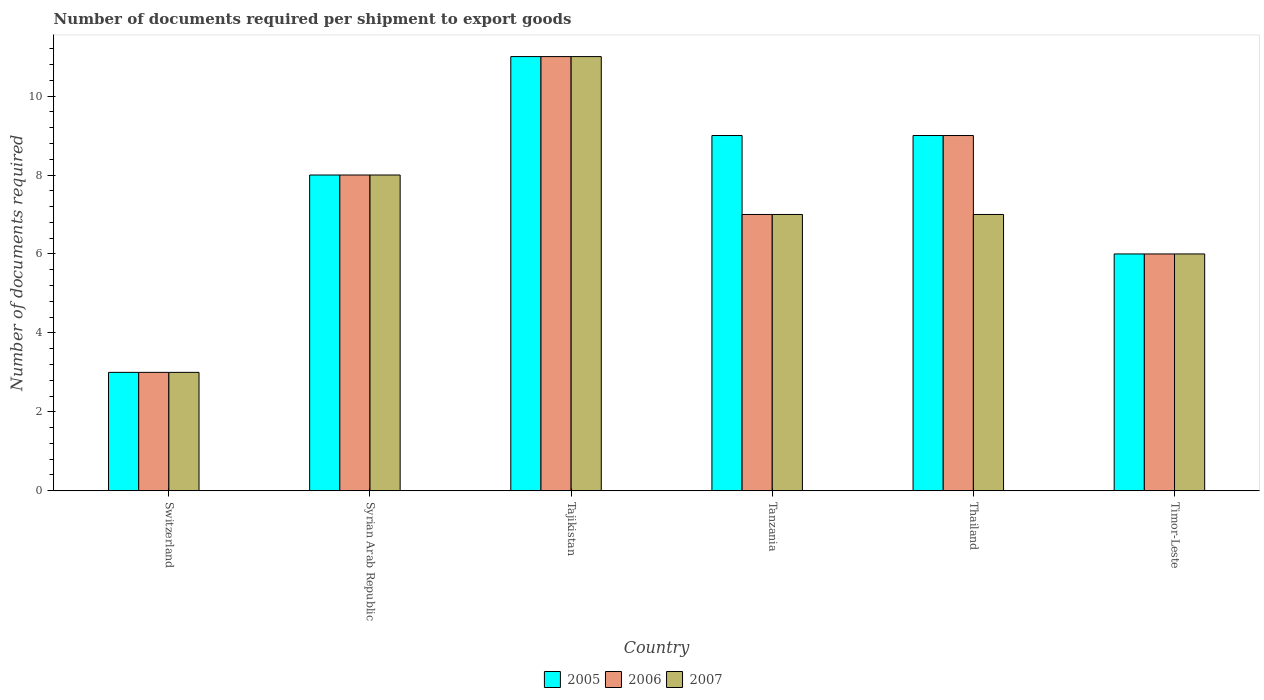How many different coloured bars are there?
Give a very brief answer. 3. Are the number of bars per tick equal to the number of legend labels?
Your response must be concise. Yes. How many bars are there on the 3rd tick from the left?
Provide a succinct answer. 3. How many bars are there on the 3rd tick from the right?
Offer a terse response. 3. What is the label of the 2nd group of bars from the left?
Your response must be concise. Syrian Arab Republic. What is the number of documents required per shipment to export goods in 2006 in Syrian Arab Republic?
Keep it short and to the point. 8. In which country was the number of documents required per shipment to export goods in 2007 maximum?
Keep it short and to the point. Tajikistan. In which country was the number of documents required per shipment to export goods in 2006 minimum?
Provide a succinct answer. Switzerland. What is the difference between the number of documents required per shipment to export goods in 2006 in Switzerland and that in Syrian Arab Republic?
Make the answer very short. -5. What is the average number of documents required per shipment to export goods in 2006 per country?
Ensure brevity in your answer.  7.33. What is the difference between the number of documents required per shipment to export goods of/in 2006 and number of documents required per shipment to export goods of/in 2005 in Thailand?
Provide a short and direct response. 0. In how many countries, is the number of documents required per shipment to export goods in 2007 greater than 4?
Your answer should be very brief. 5. What is the ratio of the number of documents required per shipment to export goods in 2007 in Syrian Arab Republic to that in Tanzania?
Offer a very short reply. 1.14. Is the number of documents required per shipment to export goods in 2007 in Tajikistan less than that in Timor-Leste?
Keep it short and to the point. No. Is the difference between the number of documents required per shipment to export goods in 2006 in Switzerland and Tanzania greater than the difference between the number of documents required per shipment to export goods in 2005 in Switzerland and Tanzania?
Keep it short and to the point. Yes. In how many countries, is the number of documents required per shipment to export goods in 2007 greater than the average number of documents required per shipment to export goods in 2007 taken over all countries?
Keep it short and to the point. 2. Is the sum of the number of documents required per shipment to export goods in 2007 in Tajikistan and Timor-Leste greater than the maximum number of documents required per shipment to export goods in 2005 across all countries?
Offer a very short reply. Yes. Is it the case that in every country, the sum of the number of documents required per shipment to export goods in 2005 and number of documents required per shipment to export goods in 2007 is greater than the number of documents required per shipment to export goods in 2006?
Ensure brevity in your answer.  Yes. Are all the bars in the graph horizontal?
Offer a very short reply. No. How many countries are there in the graph?
Provide a short and direct response. 6. What is the difference between two consecutive major ticks on the Y-axis?
Your response must be concise. 2. Does the graph contain grids?
Offer a terse response. No. How many legend labels are there?
Ensure brevity in your answer.  3. How are the legend labels stacked?
Ensure brevity in your answer.  Horizontal. What is the title of the graph?
Ensure brevity in your answer.  Number of documents required per shipment to export goods. Does "1988" appear as one of the legend labels in the graph?
Your response must be concise. No. What is the label or title of the X-axis?
Offer a very short reply. Country. What is the label or title of the Y-axis?
Provide a short and direct response. Number of documents required. What is the Number of documents required in 2005 in Switzerland?
Ensure brevity in your answer.  3. What is the Number of documents required of 2006 in Switzerland?
Make the answer very short. 3. What is the Number of documents required in 2007 in Switzerland?
Ensure brevity in your answer.  3. What is the Number of documents required of 2005 in Syrian Arab Republic?
Provide a succinct answer. 8. What is the Number of documents required of 2006 in Syrian Arab Republic?
Ensure brevity in your answer.  8. What is the Number of documents required in 2007 in Syrian Arab Republic?
Provide a succinct answer. 8. What is the Number of documents required in 2005 in Tajikistan?
Your response must be concise. 11. What is the Number of documents required in 2007 in Tajikistan?
Your answer should be compact. 11. What is the Number of documents required in 2005 in Tanzania?
Your answer should be compact. 9. What is the Number of documents required of 2006 in Tanzania?
Keep it short and to the point. 7. What is the Number of documents required of 2007 in Tanzania?
Provide a succinct answer. 7. What is the Number of documents required of 2005 in Thailand?
Provide a short and direct response. 9. What is the Number of documents required of 2006 in Thailand?
Make the answer very short. 9. What is the Number of documents required in 2005 in Timor-Leste?
Your answer should be compact. 6. What is the Number of documents required in 2007 in Timor-Leste?
Your answer should be compact. 6. Across all countries, what is the minimum Number of documents required of 2006?
Ensure brevity in your answer.  3. What is the total Number of documents required in 2005 in the graph?
Give a very brief answer. 46. What is the total Number of documents required of 2006 in the graph?
Your response must be concise. 44. What is the difference between the Number of documents required in 2005 in Switzerland and that in Syrian Arab Republic?
Provide a succinct answer. -5. What is the difference between the Number of documents required of 2006 in Switzerland and that in Syrian Arab Republic?
Make the answer very short. -5. What is the difference between the Number of documents required in 2007 in Switzerland and that in Syrian Arab Republic?
Your answer should be very brief. -5. What is the difference between the Number of documents required in 2005 in Switzerland and that in Tajikistan?
Provide a succinct answer. -8. What is the difference between the Number of documents required in 2006 in Switzerland and that in Tajikistan?
Your answer should be compact. -8. What is the difference between the Number of documents required in 2007 in Switzerland and that in Tajikistan?
Your answer should be very brief. -8. What is the difference between the Number of documents required in 2007 in Switzerland and that in Tanzania?
Keep it short and to the point. -4. What is the difference between the Number of documents required in 2005 in Switzerland and that in Thailand?
Offer a very short reply. -6. What is the difference between the Number of documents required of 2007 in Switzerland and that in Thailand?
Give a very brief answer. -4. What is the difference between the Number of documents required of 2005 in Switzerland and that in Timor-Leste?
Your response must be concise. -3. What is the difference between the Number of documents required of 2007 in Switzerland and that in Timor-Leste?
Offer a terse response. -3. What is the difference between the Number of documents required in 2006 in Syrian Arab Republic and that in Tajikistan?
Your answer should be compact. -3. What is the difference between the Number of documents required in 2006 in Syrian Arab Republic and that in Tanzania?
Ensure brevity in your answer.  1. What is the difference between the Number of documents required in 2005 in Syrian Arab Republic and that in Thailand?
Offer a terse response. -1. What is the difference between the Number of documents required in 2006 in Syrian Arab Republic and that in Thailand?
Your answer should be very brief. -1. What is the difference between the Number of documents required of 2005 in Tajikistan and that in Tanzania?
Offer a very short reply. 2. What is the difference between the Number of documents required in 2007 in Tajikistan and that in Tanzania?
Your answer should be compact. 4. What is the difference between the Number of documents required of 2005 in Tajikistan and that in Thailand?
Offer a terse response. 2. What is the difference between the Number of documents required in 2006 in Tajikistan and that in Thailand?
Your response must be concise. 2. What is the difference between the Number of documents required of 2005 in Tajikistan and that in Timor-Leste?
Your answer should be compact. 5. What is the difference between the Number of documents required in 2006 in Tajikistan and that in Timor-Leste?
Your response must be concise. 5. What is the difference between the Number of documents required of 2007 in Tanzania and that in Thailand?
Ensure brevity in your answer.  0. What is the difference between the Number of documents required of 2005 in Tanzania and that in Timor-Leste?
Provide a short and direct response. 3. What is the difference between the Number of documents required in 2006 in Tanzania and that in Timor-Leste?
Provide a succinct answer. 1. What is the difference between the Number of documents required in 2005 in Thailand and that in Timor-Leste?
Your answer should be very brief. 3. What is the difference between the Number of documents required in 2006 in Thailand and that in Timor-Leste?
Your response must be concise. 3. What is the difference between the Number of documents required of 2005 in Switzerland and the Number of documents required of 2007 in Syrian Arab Republic?
Make the answer very short. -5. What is the difference between the Number of documents required of 2006 in Switzerland and the Number of documents required of 2007 in Syrian Arab Republic?
Provide a succinct answer. -5. What is the difference between the Number of documents required of 2005 in Switzerland and the Number of documents required of 2007 in Tanzania?
Give a very brief answer. -4. What is the difference between the Number of documents required in 2005 in Switzerland and the Number of documents required in 2006 in Thailand?
Ensure brevity in your answer.  -6. What is the difference between the Number of documents required in 2006 in Switzerland and the Number of documents required in 2007 in Thailand?
Your answer should be compact. -4. What is the difference between the Number of documents required of 2006 in Switzerland and the Number of documents required of 2007 in Timor-Leste?
Your response must be concise. -3. What is the difference between the Number of documents required of 2006 in Syrian Arab Republic and the Number of documents required of 2007 in Tajikistan?
Your answer should be compact. -3. What is the difference between the Number of documents required in 2005 in Syrian Arab Republic and the Number of documents required in 2006 in Tanzania?
Your response must be concise. 1. What is the difference between the Number of documents required in 2005 in Syrian Arab Republic and the Number of documents required in 2007 in Tanzania?
Your answer should be compact. 1. What is the difference between the Number of documents required in 2006 in Syrian Arab Republic and the Number of documents required in 2007 in Tanzania?
Provide a succinct answer. 1. What is the difference between the Number of documents required in 2005 in Syrian Arab Republic and the Number of documents required in 2006 in Timor-Leste?
Ensure brevity in your answer.  2. What is the difference between the Number of documents required of 2005 in Syrian Arab Republic and the Number of documents required of 2007 in Timor-Leste?
Provide a short and direct response. 2. What is the difference between the Number of documents required in 2006 in Syrian Arab Republic and the Number of documents required in 2007 in Timor-Leste?
Give a very brief answer. 2. What is the difference between the Number of documents required in 2005 in Tajikistan and the Number of documents required in 2006 in Tanzania?
Your answer should be compact. 4. What is the difference between the Number of documents required of 2005 in Tajikistan and the Number of documents required of 2006 in Thailand?
Ensure brevity in your answer.  2. What is the difference between the Number of documents required of 2005 in Tajikistan and the Number of documents required of 2006 in Timor-Leste?
Make the answer very short. 5. What is the difference between the Number of documents required of 2005 in Tajikistan and the Number of documents required of 2007 in Timor-Leste?
Keep it short and to the point. 5. What is the difference between the Number of documents required of 2006 in Tajikistan and the Number of documents required of 2007 in Timor-Leste?
Offer a very short reply. 5. What is the difference between the Number of documents required of 2005 in Tanzania and the Number of documents required of 2006 in Thailand?
Provide a succinct answer. 0. What is the difference between the Number of documents required in 2005 in Tanzania and the Number of documents required in 2007 in Thailand?
Ensure brevity in your answer.  2. What is the difference between the Number of documents required of 2006 in Tanzania and the Number of documents required of 2007 in Thailand?
Your answer should be compact. 0. What is the difference between the Number of documents required in 2005 in Thailand and the Number of documents required in 2006 in Timor-Leste?
Provide a succinct answer. 3. What is the difference between the Number of documents required in 2006 in Thailand and the Number of documents required in 2007 in Timor-Leste?
Keep it short and to the point. 3. What is the average Number of documents required of 2005 per country?
Offer a terse response. 7.67. What is the average Number of documents required of 2006 per country?
Ensure brevity in your answer.  7.33. What is the average Number of documents required of 2007 per country?
Your answer should be compact. 7. What is the difference between the Number of documents required of 2005 and Number of documents required of 2006 in Switzerland?
Ensure brevity in your answer.  0. What is the difference between the Number of documents required of 2006 and Number of documents required of 2007 in Switzerland?
Ensure brevity in your answer.  0. What is the difference between the Number of documents required of 2006 and Number of documents required of 2007 in Syrian Arab Republic?
Offer a terse response. 0. What is the difference between the Number of documents required in 2005 and Number of documents required in 2006 in Tajikistan?
Your response must be concise. 0. What is the difference between the Number of documents required of 2005 and Number of documents required of 2006 in Tanzania?
Provide a short and direct response. 2. What is the difference between the Number of documents required of 2006 and Number of documents required of 2007 in Tanzania?
Ensure brevity in your answer.  0. What is the difference between the Number of documents required in 2005 and Number of documents required in 2007 in Thailand?
Give a very brief answer. 2. What is the difference between the Number of documents required of 2005 and Number of documents required of 2006 in Timor-Leste?
Give a very brief answer. 0. What is the difference between the Number of documents required in 2005 and Number of documents required in 2007 in Timor-Leste?
Offer a terse response. 0. What is the ratio of the Number of documents required of 2006 in Switzerland to that in Syrian Arab Republic?
Your answer should be compact. 0.38. What is the ratio of the Number of documents required of 2005 in Switzerland to that in Tajikistan?
Your answer should be compact. 0.27. What is the ratio of the Number of documents required of 2006 in Switzerland to that in Tajikistan?
Provide a succinct answer. 0.27. What is the ratio of the Number of documents required in 2007 in Switzerland to that in Tajikistan?
Your answer should be very brief. 0.27. What is the ratio of the Number of documents required in 2005 in Switzerland to that in Tanzania?
Offer a very short reply. 0.33. What is the ratio of the Number of documents required in 2006 in Switzerland to that in Tanzania?
Your answer should be compact. 0.43. What is the ratio of the Number of documents required in 2007 in Switzerland to that in Tanzania?
Provide a succinct answer. 0.43. What is the ratio of the Number of documents required in 2005 in Switzerland to that in Thailand?
Give a very brief answer. 0.33. What is the ratio of the Number of documents required in 2007 in Switzerland to that in Thailand?
Provide a short and direct response. 0.43. What is the ratio of the Number of documents required of 2005 in Switzerland to that in Timor-Leste?
Your answer should be very brief. 0.5. What is the ratio of the Number of documents required of 2006 in Switzerland to that in Timor-Leste?
Ensure brevity in your answer.  0.5. What is the ratio of the Number of documents required in 2005 in Syrian Arab Republic to that in Tajikistan?
Provide a succinct answer. 0.73. What is the ratio of the Number of documents required in 2006 in Syrian Arab Republic to that in Tajikistan?
Make the answer very short. 0.73. What is the ratio of the Number of documents required of 2007 in Syrian Arab Republic to that in Tajikistan?
Your answer should be compact. 0.73. What is the ratio of the Number of documents required in 2006 in Syrian Arab Republic to that in Tanzania?
Your answer should be compact. 1.14. What is the ratio of the Number of documents required of 2006 in Syrian Arab Republic to that in Thailand?
Offer a terse response. 0.89. What is the ratio of the Number of documents required in 2005 in Syrian Arab Republic to that in Timor-Leste?
Provide a short and direct response. 1.33. What is the ratio of the Number of documents required in 2006 in Syrian Arab Republic to that in Timor-Leste?
Ensure brevity in your answer.  1.33. What is the ratio of the Number of documents required of 2005 in Tajikistan to that in Tanzania?
Your answer should be compact. 1.22. What is the ratio of the Number of documents required of 2006 in Tajikistan to that in Tanzania?
Make the answer very short. 1.57. What is the ratio of the Number of documents required in 2007 in Tajikistan to that in Tanzania?
Provide a short and direct response. 1.57. What is the ratio of the Number of documents required of 2005 in Tajikistan to that in Thailand?
Ensure brevity in your answer.  1.22. What is the ratio of the Number of documents required in 2006 in Tajikistan to that in Thailand?
Offer a very short reply. 1.22. What is the ratio of the Number of documents required in 2007 in Tajikistan to that in Thailand?
Make the answer very short. 1.57. What is the ratio of the Number of documents required of 2005 in Tajikistan to that in Timor-Leste?
Make the answer very short. 1.83. What is the ratio of the Number of documents required in 2006 in Tajikistan to that in Timor-Leste?
Ensure brevity in your answer.  1.83. What is the ratio of the Number of documents required of 2007 in Tajikistan to that in Timor-Leste?
Ensure brevity in your answer.  1.83. What is the ratio of the Number of documents required in 2005 in Tanzania to that in Thailand?
Ensure brevity in your answer.  1. What is the ratio of the Number of documents required of 2006 in Tanzania to that in Thailand?
Keep it short and to the point. 0.78. What is the ratio of the Number of documents required of 2007 in Tanzania to that in Thailand?
Your answer should be very brief. 1. What is the ratio of the Number of documents required of 2006 in Tanzania to that in Timor-Leste?
Provide a short and direct response. 1.17. What is the ratio of the Number of documents required of 2007 in Tanzania to that in Timor-Leste?
Keep it short and to the point. 1.17. What is the ratio of the Number of documents required in 2005 in Thailand to that in Timor-Leste?
Ensure brevity in your answer.  1.5. What is the ratio of the Number of documents required of 2006 in Thailand to that in Timor-Leste?
Your answer should be compact. 1.5. What is the difference between the highest and the second highest Number of documents required of 2006?
Your response must be concise. 2. What is the difference between the highest and the lowest Number of documents required in 2005?
Give a very brief answer. 8. 